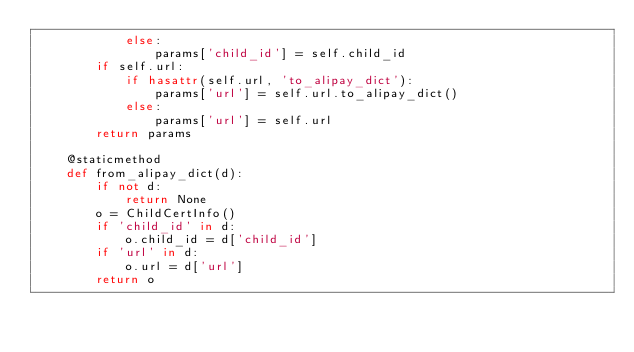<code> <loc_0><loc_0><loc_500><loc_500><_Python_>            else:
                params['child_id'] = self.child_id
        if self.url:
            if hasattr(self.url, 'to_alipay_dict'):
                params['url'] = self.url.to_alipay_dict()
            else:
                params['url'] = self.url
        return params

    @staticmethod
    def from_alipay_dict(d):
        if not d:
            return None
        o = ChildCertInfo()
        if 'child_id' in d:
            o.child_id = d['child_id']
        if 'url' in d:
            o.url = d['url']
        return o


</code> 